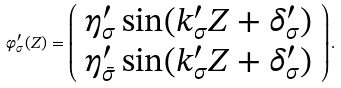<formula> <loc_0><loc_0><loc_500><loc_500>\varphi _ { \sigma } ^ { \prime } ( Z ) = \left ( \begin{array} { c } \eta _ { \sigma } ^ { \prime } \sin ( k _ { \sigma } ^ { \prime } Z + \delta _ { \sigma } ^ { \prime } ) \\ \eta _ { \bar { \sigma } } ^ { \prime } \sin ( k _ { \sigma } ^ { \prime } Z + \delta _ { \sigma } ^ { \prime } ) \end{array} \right ) .</formula> 